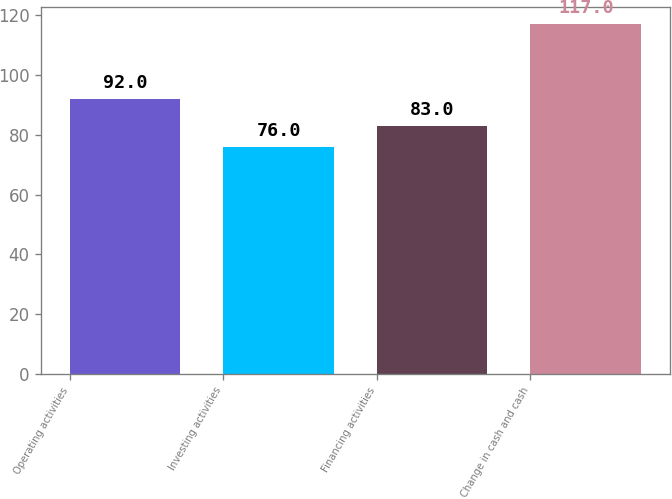<chart> <loc_0><loc_0><loc_500><loc_500><bar_chart><fcel>Operating activities<fcel>Investing activities<fcel>Financing activities<fcel>Change in cash and cash<nl><fcel>92<fcel>76<fcel>83<fcel>117<nl></chart> 